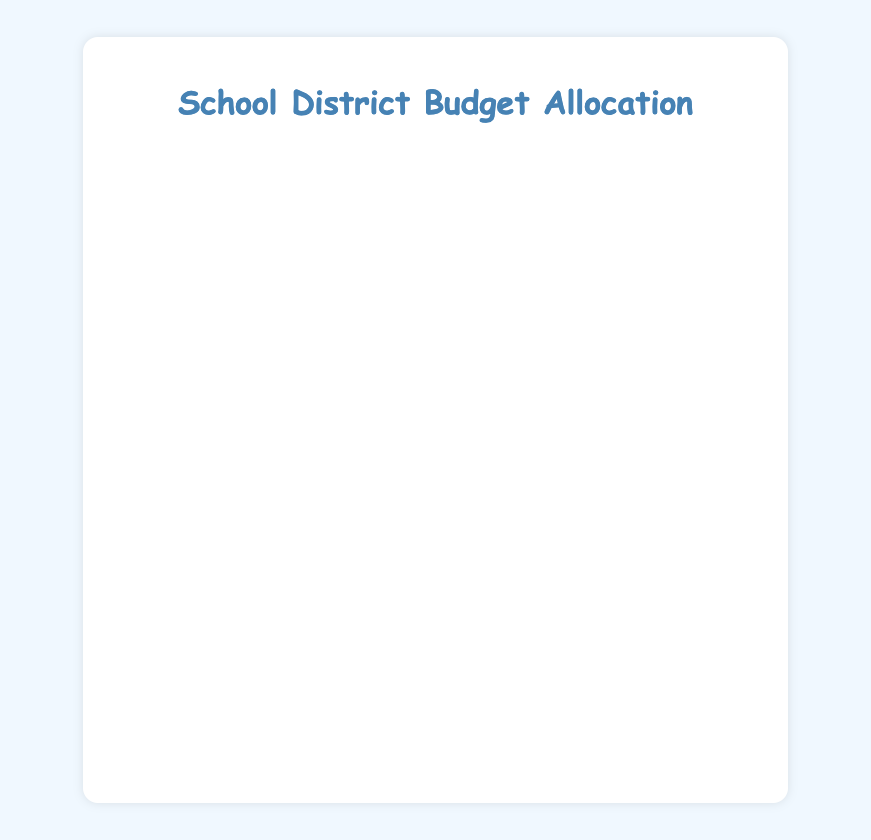Which expense category has the highest allocation percentage? The largest bar on the chart indicates that 'Teacher Salaries' receive the highest allocation, with 50% of the total budget.
Answer: Teacher Salaries How much more is allocated to Teacher Salaries compared to Support Staff Salaries? Teacher Salaries are allocated 50% and Support Staff Salaries 10%. The difference is 50% - 10% = 40%.
Answer: 40% What is the combined percentage allocation for Technology and Equipment and Professional Development? Both 'Technology and Equipment' and 'Professional Development' are allocated 3% each. Adding them, 3% + 3% = 6%.
Answer: 6% Which category has the same percentage allocation as Extracurricular Activities? Both 'Extracurricular Activities' and 'Counseling and Mental Health Services' are allocated 2% of the budget.
Answer: Counseling and Mental Health Services Does Facilities Maintenance receive a higher budget allocation than Special Education Programs? Facilities Maintenance is allocated 9%, while Special Education Programs receive 7%. Therefore, Facilities Maintenance has a higher allocation.
Answer: Yes What is the combined total percentage for Administrative Costs, Student Transportation, and Instructional Materials? Administrative Costs have 6%, Student Transportation has 5%, and Instructional Materials have 4%. Adding them together, 6% + 5% + 4% = 15%.
Answer: 15% Which three categories receive the lowest budget allocation? The categories with the smallest bars are 'Extracurricular Activities', 'Counseling and Mental Health Services', and 'Technology and Equipment', each with 2%, 2%, and 3% respectively.
Answer: Extracurricular Activities, Counseling and Mental Health Services, Technology and Equipment How much less is allocated to Administrative Costs compared to Teacher Salaries in percentage terms? Administrative Costs are allocated 6% while Teacher Salaries receive 50%. The difference is 50% - 6% = 44%.
Answer: 44% Does Instructional Materials allocation fall below the average percentage allocation across all categories? The total budget percentage is 100% divided by 11 categories gives an average of approximately 9.1%. 'Instructional Materials' with 4% is below this average.
Answer: Yes What is the total dollar amount allocated to categories under 5%? Categories under 5% are 'Student Transportation' (5%), 'Technology and Equipment' (3%), 'Extracurricular Activities' (2%), 'Professional Development' (3%), and 'Counseling and Mental Health Services' (2%). Summing their dollar amounts: $350,000 + $210,000 + $140,000 + $210,000 + $140,000 = $1,050,000.
Answer: $1,050,000 